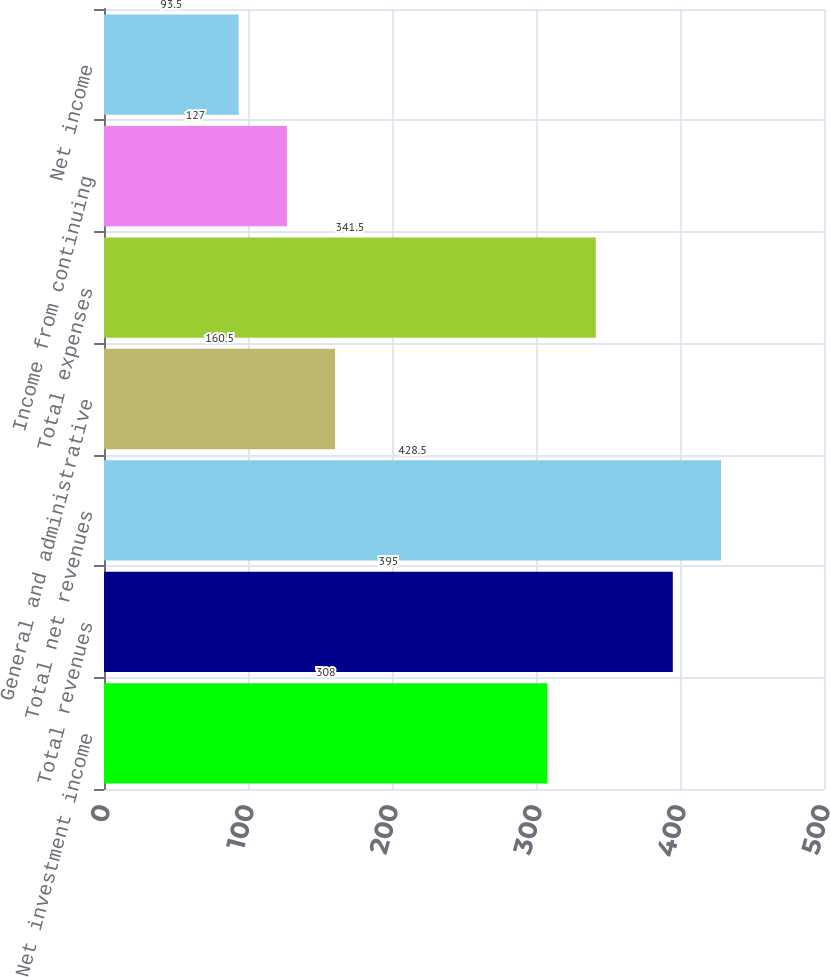Convert chart. <chart><loc_0><loc_0><loc_500><loc_500><bar_chart><fcel>Net investment income<fcel>Total revenues<fcel>Total net revenues<fcel>General and administrative<fcel>Total expenses<fcel>Income from continuing<fcel>Net income<nl><fcel>308<fcel>395<fcel>428.5<fcel>160.5<fcel>341.5<fcel>127<fcel>93.5<nl></chart> 